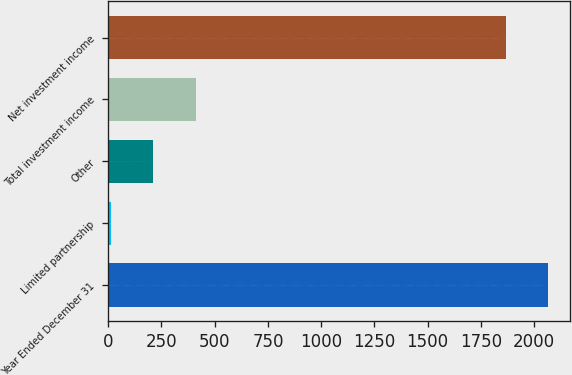Convert chart to OTSL. <chart><loc_0><loc_0><loc_500><loc_500><bar_chart><fcel>Year Ended December 31<fcel>Limited partnership<fcel>Other<fcel>Total investment income<fcel>Net investment income<nl><fcel>2066.4<fcel>11<fcel>211.4<fcel>411.8<fcel>1866<nl></chart> 